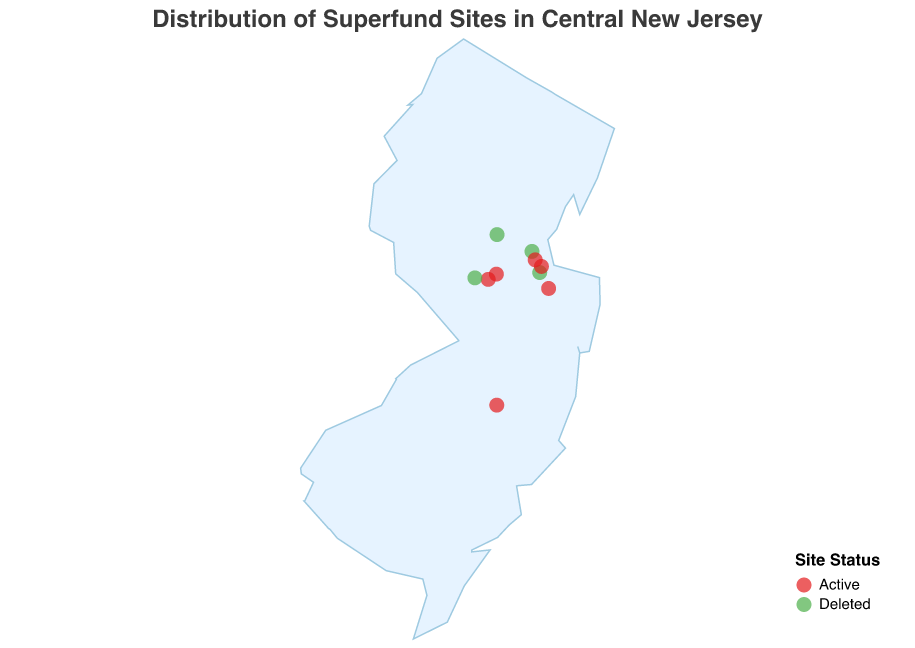What is the title of the figure? The title is typically found at the top of the figure, and in this case, it is clearly stated as "Distribution of Superfund Sites in Central New Jersey."
Answer: Distribution of Superfund Sites in Central New Jersey How many Superfund sites are depicted in the figure? Counting all the data points from the data layer reveals the total number of Superfund sites represented.
Answer: 10 Which county has the most Superfund sites? By counting the number of data points associated with each county, we can determine that Middlesex County has the most sites.
Answer: Middlesex How many "Active" and "Deleted" Superfund sites are there in Somerset County? By filtering the data points to only include Somerset County and then counting the number with each status, we see there is 1 Active site and 1 Deleted site.
Answer: 1 Active, 1 Deleted What is the geographical range of the Superfund sites in terms of latitude? By examining the data points for the minimum and maximum latitude values, we determine that the range is from 39.8861 to 40.5742.
Answer: 39.8861 to 40.5742 Which Superfund site is located farthest to the west in Central New Jersey? By comparing the longitude coordinates, the site with the smallest (most negative) longitude value is identified. Rocky Hill Municipal Well in Somerset County is located at -74.6392.
Answer: Rocky Hill Municipal Well What is the latitude and longitude of the "Imperial Oil Co. Inc./Champion Chemicals" site? Referring to the data point associated with this site, its coordinates are 40.4462 latitude and -74.2875 longitude.
Answer: 40.4462, -74.2875 Which Superfund site in Central New Jersey is nearest to "Marlboro Municipal Landfill"? By calculating the Euclidean distances between the "Marlboro Municipal Landfill" coordinates and other sites, "Bog Creek Farm" appears to be the nearest.
Answer: Bog Creek Farm How many counties in Central New Jersey have at least one Superfund site depicted in the figure? By listing all the unique counties present in the data, there are four: Monmouth, Middlesex, Somerset, and Burlington.
Answer: 4 Which sites in Middlesex County are "Active"? Filtering the data points for Middlesex County and checking their status reveals that 'Imperial Oil Co. Inc./Champion Chemicals', 'Sayreville Landfill', and 'South Brunswick Landfill' are active.
Answer: Imperial Oil Co. Inc./Champion Chemicals, Sayreville Landfill, South Brunswick Landfill 